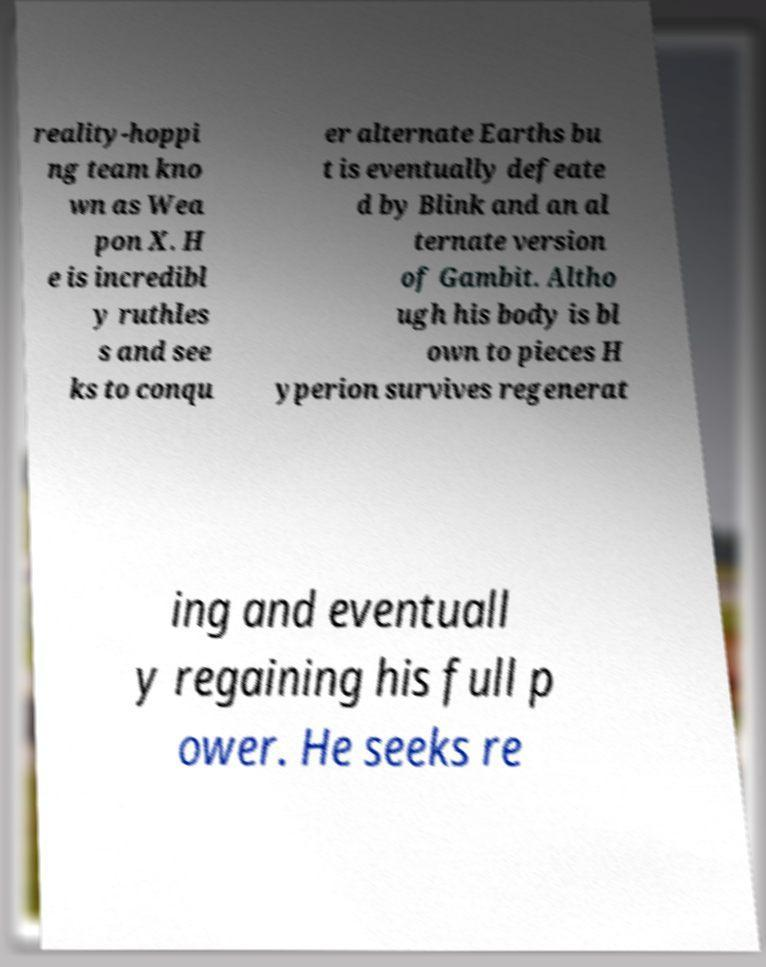There's text embedded in this image that I need extracted. Can you transcribe it verbatim? reality-hoppi ng team kno wn as Wea pon X. H e is incredibl y ruthles s and see ks to conqu er alternate Earths bu t is eventually defeate d by Blink and an al ternate version of Gambit. Altho ugh his body is bl own to pieces H yperion survives regenerat ing and eventuall y regaining his full p ower. He seeks re 